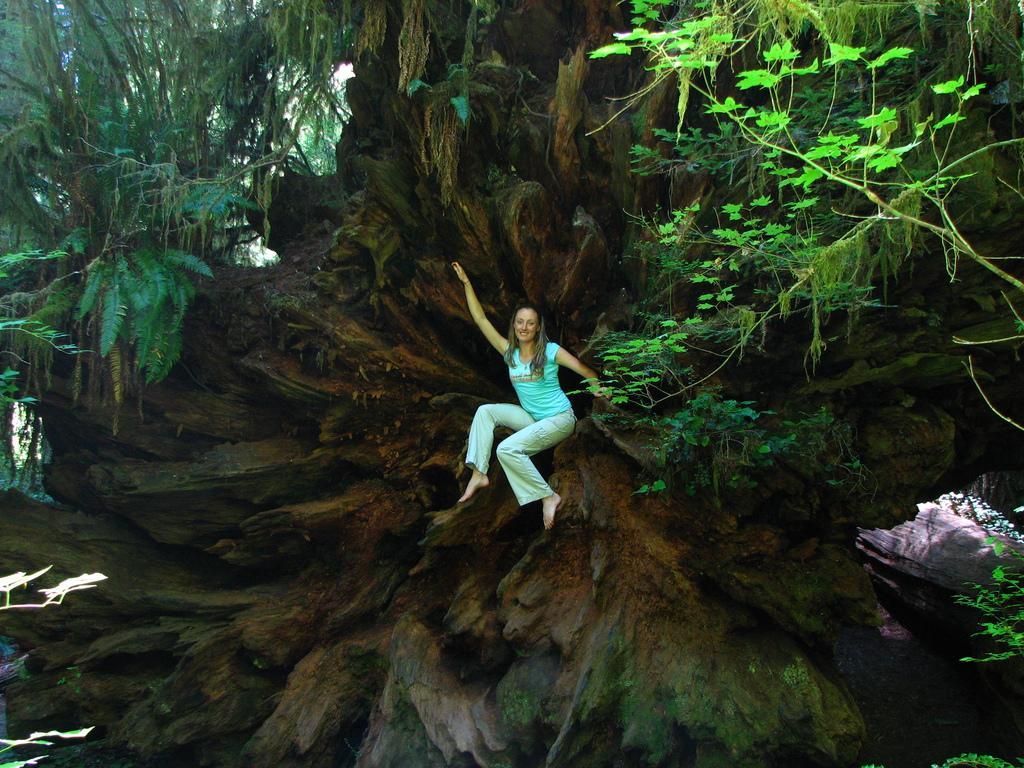Could you give a brief overview of what you see in this image? In the picture there is a woman sitting on a branch of a tree, there are trees present. 